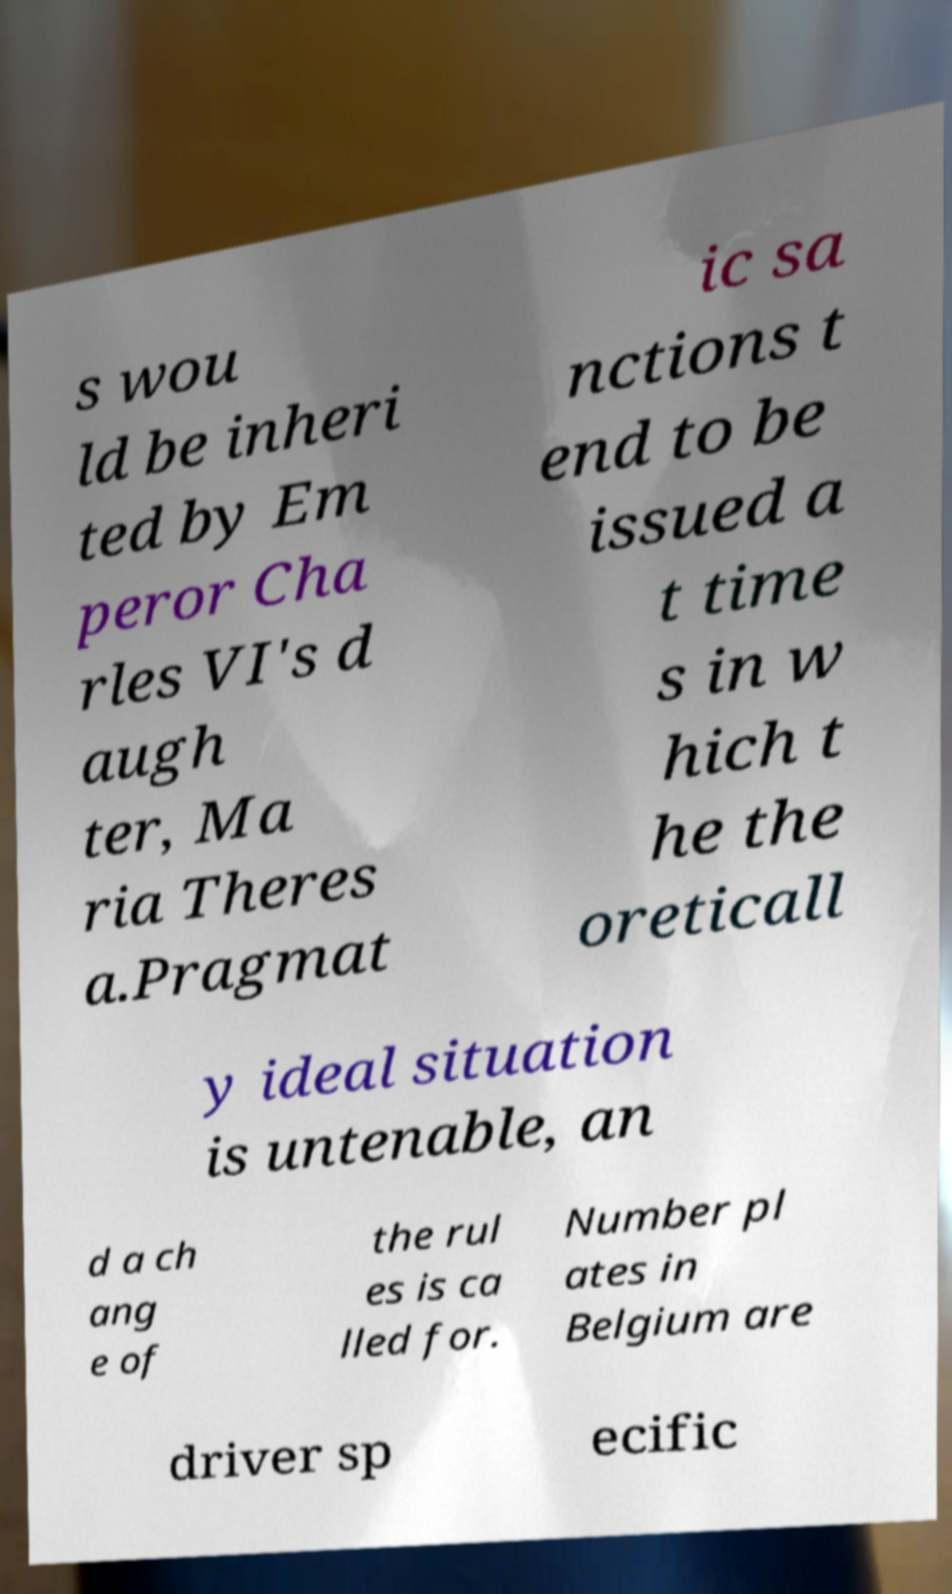For documentation purposes, I need the text within this image transcribed. Could you provide that? s wou ld be inheri ted by Em peror Cha rles VI's d augh ter, Ma ria Theres a.Pragmat ic sa nctions t end to be issued a t time s in w hich t he the oreticall y ideal situation is untenable, an d a ch ang e of the rul es is ca lled for. Number pl ates in Belgium are driver sp ecific 